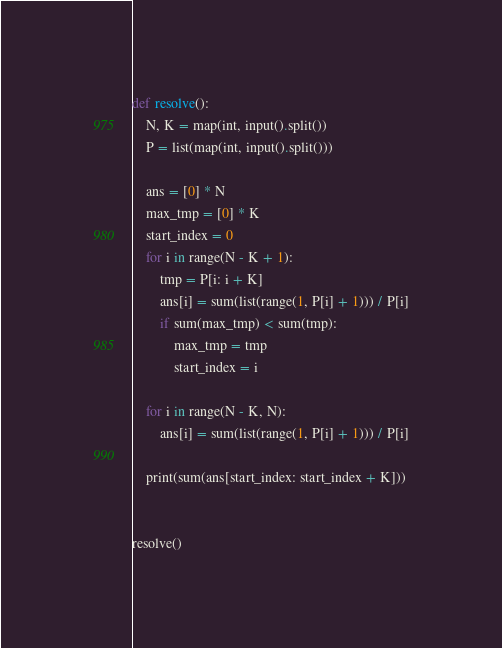<code> <loc_0><loc_0><loc_500><loc_500><_Python_>def resolve():
    N, K = map(int, input().split())
    P = list(map(int, input().split()))

    ans = [0] * N
    max_tmp = [0] * K
    start_index = 0
    for i in range(N - K + 1):
        tmp = P[i: i + K]
        ans[i] = sum(list(range(1, P[i] + 1))) / P[i]
        if sum(max_tmp) < sum(tmp):
            max_tmp = tmp
            start_index = i

    for i in range(N - K, N):
        ans[i] = sum(list(range(1, P[i] + 1))) / P[i]

    print(sum(ans[start_index: start_index + K]))


resolve()</code> 